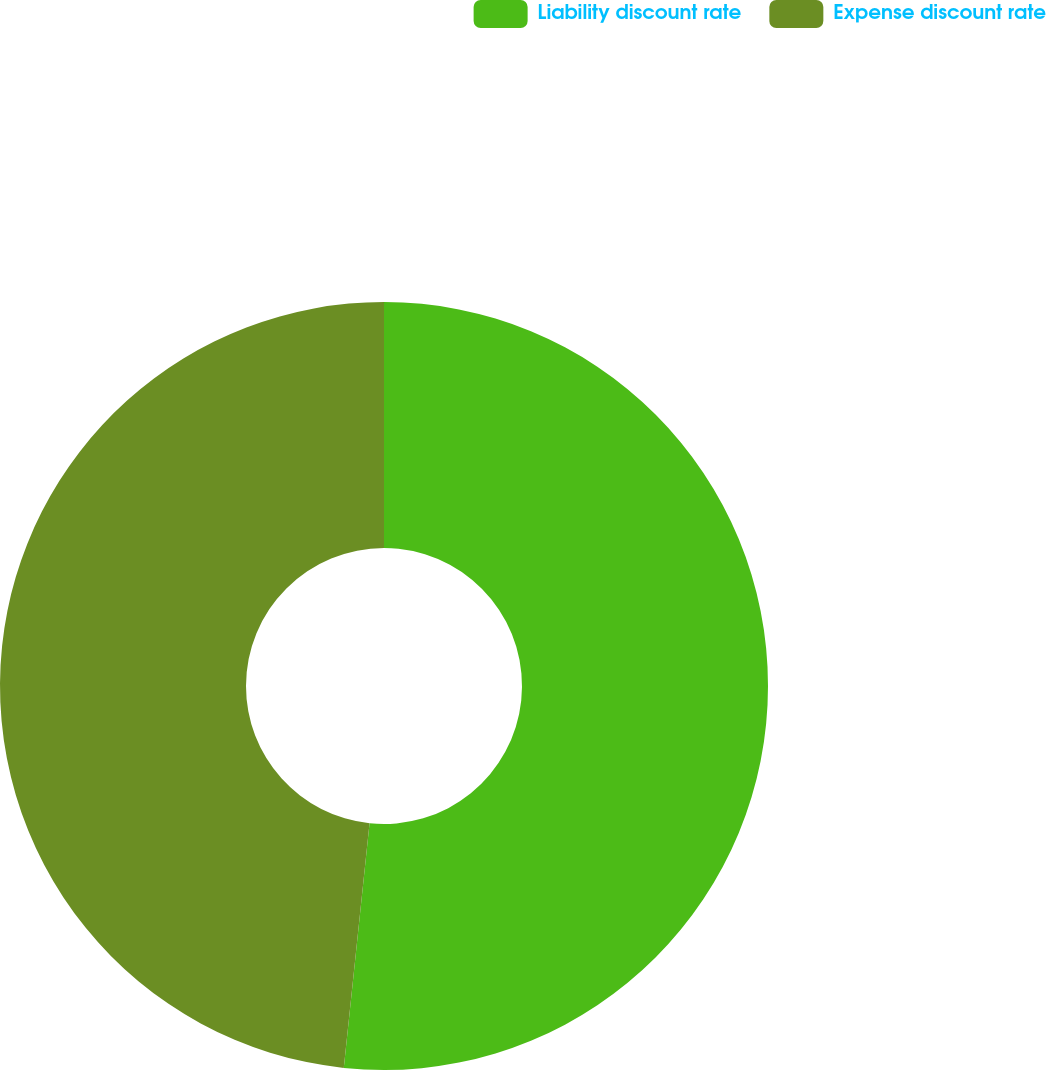Convert chart. <chart><loc_0><loc_0><loc_500><loc_500><pie_chart><fcel>Liability discount rate<fcel>Expense discount rate<nl><fcel>51.67%<fcel>48.33%<nl></chart> 